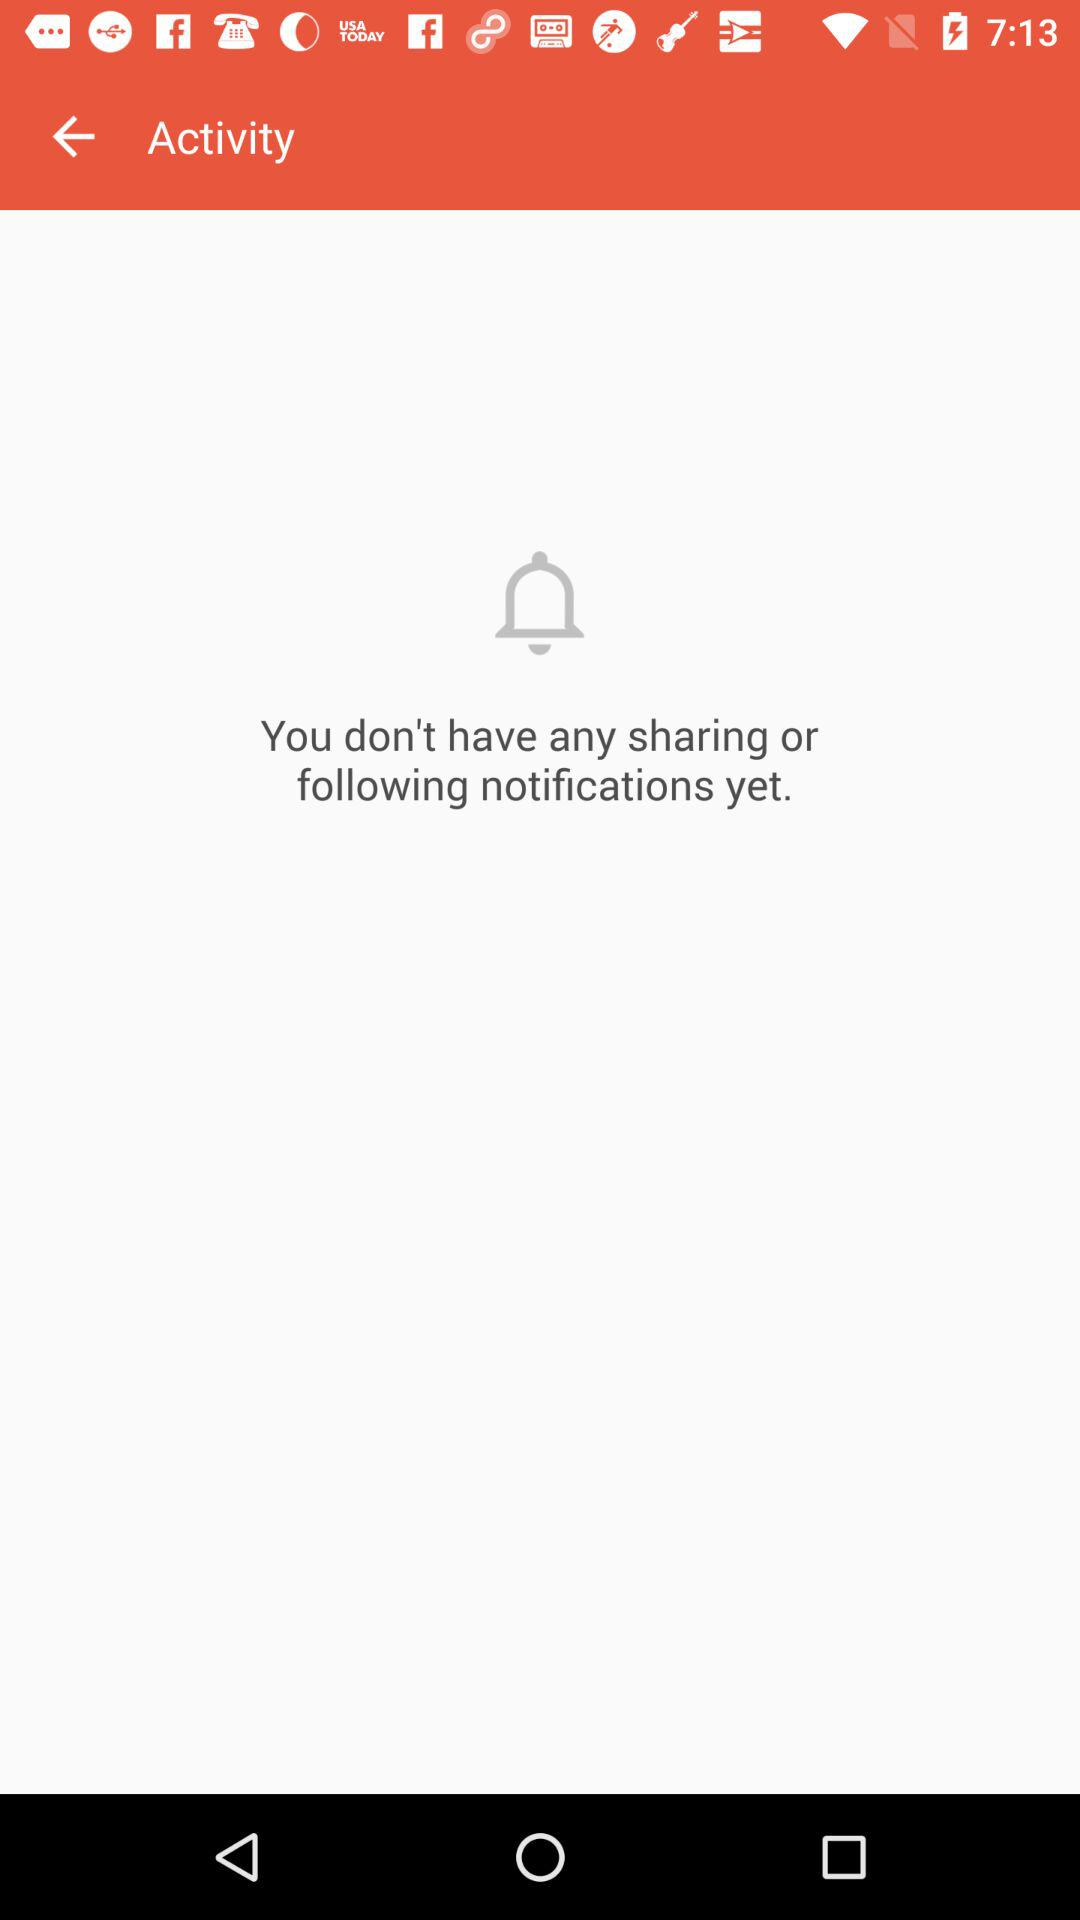How many notifications does the user have?
Answer the question using a single word or phrase. 0 